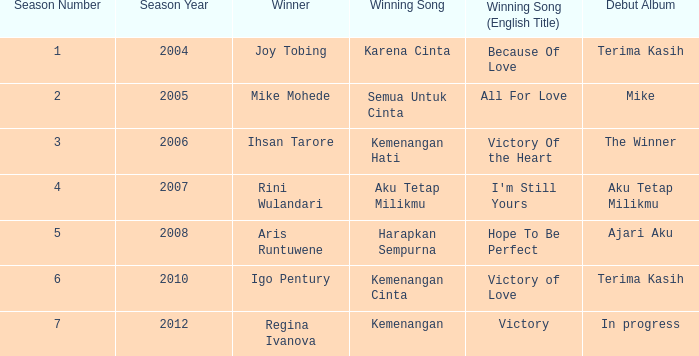Which winning song was sung by aku tetap milikmu? I'm Still Yours. 